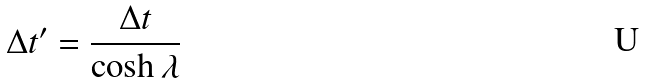<formula> <loc_0><loc_0><loc_500><loc_500>\Delta t ^ { \prime } = \frac { \Delta t } { \cosh { \lambda } }</formula> 